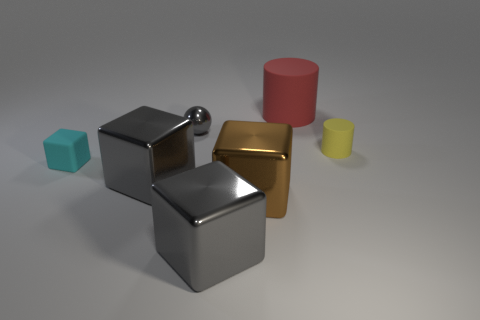Is the number of red things that are to the left of the red object greater than the number of large shiny cylinders?
Keep it short and to the point. No. How big is the matte object that is in front of the red rubber object and right of the cyan matte cube?
Keep it short and to the point. Small. What is the material of the small yellow object that is the same shape as the red object?
Your answer should be compact. Rubber. There is a metallic block that is in front of the brown block; is its size the same as the brown shiny block?
Your answer should be very brief. Yes. What color is the big thing that is behind the large brown block and on the left side of the red matte thing?
Provide a succinct answer. Gray. What number of large brown cubes are on the right side of the big red object behind the cyan cube?
Your answer should be very brief. 0. Do the yellow rubber thing and the cyan matte thing have the same shape?
Your answer should be very brief. No. Is there anything else that has the same color as the big matte thing?
Your response must be concise. No. Does the big red object have the same shape as the matte object that is to the left of the brown metal object?
Offer a very short reply. No. What is the color of the cylinder on the right side of the large thing that is behind the rubber thing in front of the small yellow matte cylinder?
Your answer should be very brief. Yellow. 